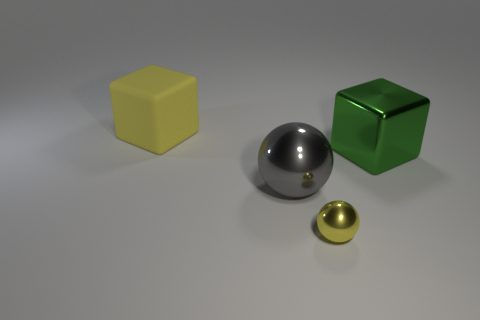Add 3 shiny blocks. How many objects exist? 7 Subtract all tiny purple metallic cylinders. Subtract all yellow shiny things. How many objects are left? 3 Add 1 tiny yellow spheres. How many tiny yellow spheres are left? 2 Add 4 brown cylinders. How many brown cylinders exist? 4 Subtract 0 purple cubes. How many objects are left? 4 